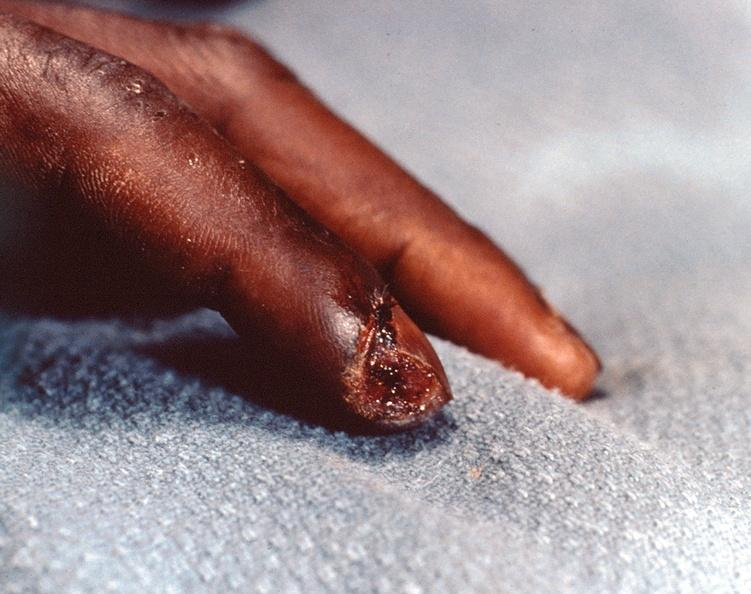does this image show necrosis of distal finger in a patient with panniculitis and fascitis?
Answer the question using a single word or phrase. Yes 